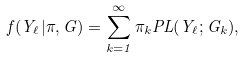<formula> <loc_0><loc_0><loc_500><loc_500>f ( Y _ { \ell } | \pi , G ) = \sum _ { k = 1 } ^ { \infty } \pi _ { k } P L ( Y _ { \ell } ; G _ { k } ) ,</formula> 